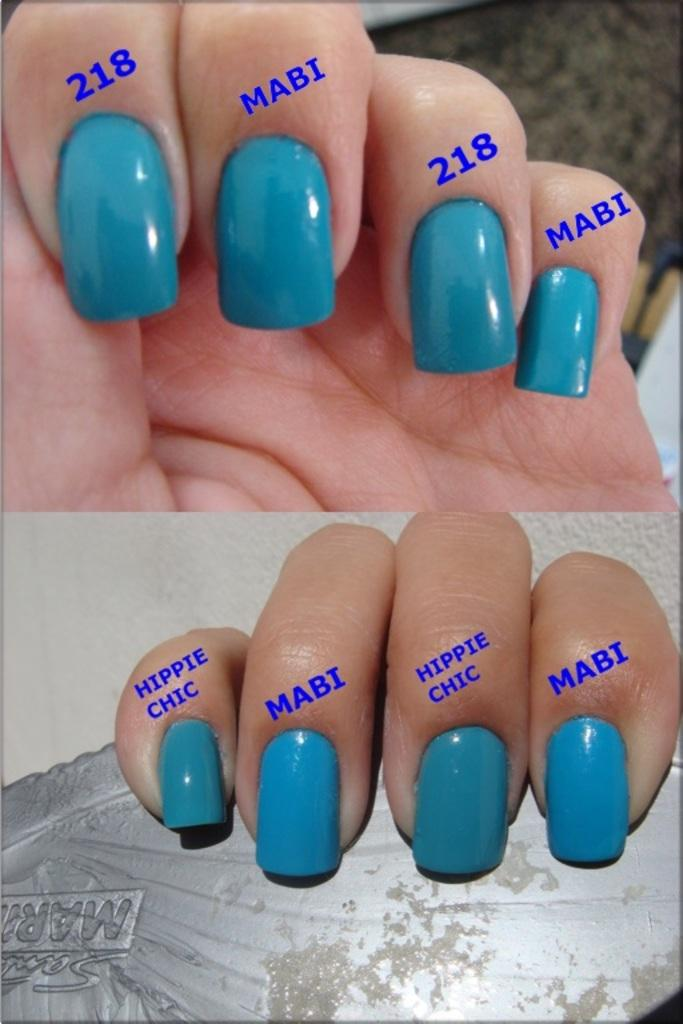<image>
Write a terse but informative summary of the picture. Two hands with turquoise fingernails and labels on each that say Hippie Chic, 218 and Mabi. 